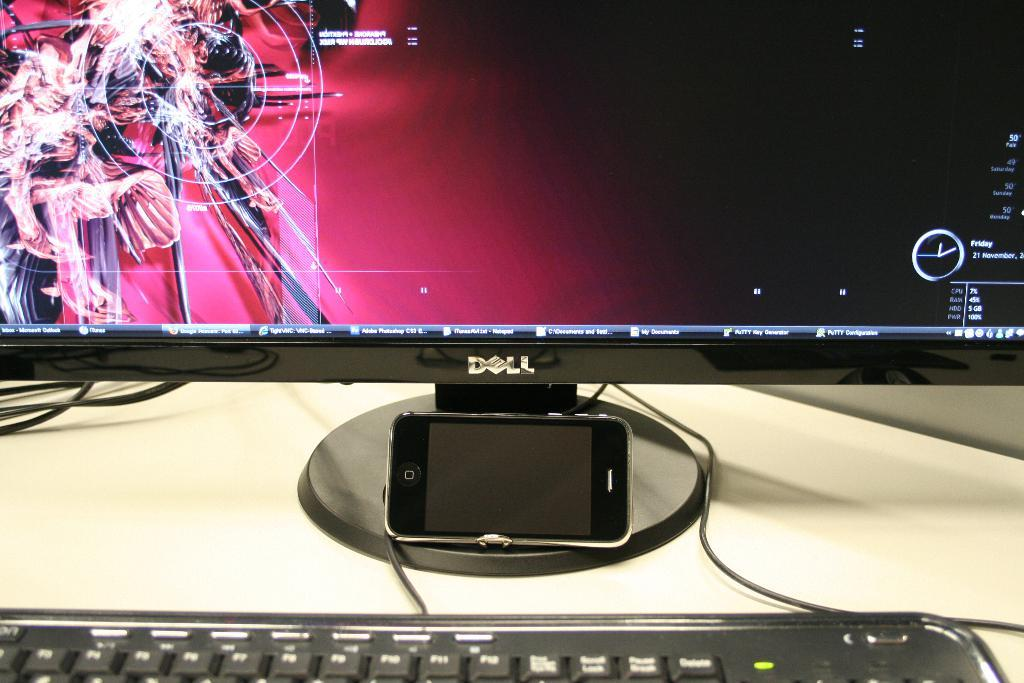<image>
Render a clear and concise summary of the photo. A monitor with a phone mounted under a logo reading "DELL". 